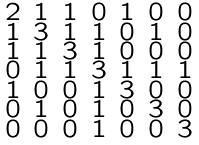<formula> <loc_0><loc_0><loc_500><loc_500>\begin{smallmatrix} 2 & 1 & 1 & 0 & 1 & 0 & 0 \\ 1 & 3 & 1 & 1 & 0 & 1 & 0 \\ 1 & 1 & 3 & 1 & 0 & 0 & 0 \\ 0 & 1 & 1 & 3 & 1 & 1 & 1 \\ 1 & 0 & 0 & 1 & 3 & 0 & 0 \\ 0 & 1 & 0 & 1 & 0 & 3 & 0 \\ 0 & 0 & 0 & 1 & 0 & 0 & 3 \end{smallmatrix}</formula> 